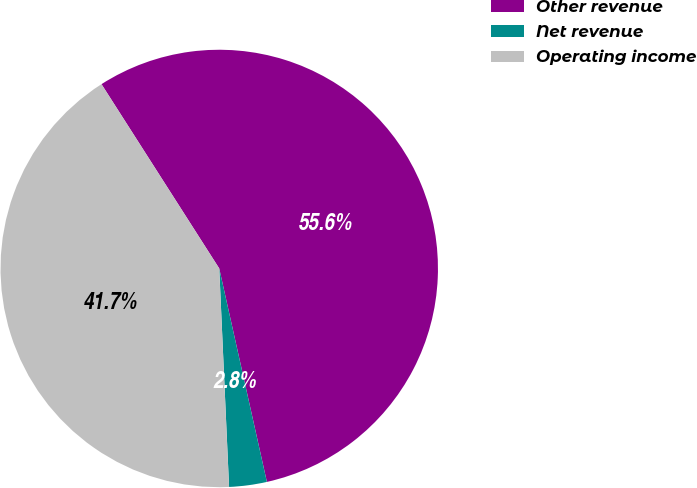<chart> <loc_0><loc_0><loc_500><loc_500><pie_chart><fcel>Other revenue<fcel>Net revenue<fcel>Operating income<nl><fcel>55.56%<fcel>2.78%<fcel>41.67%<nl></chart> 